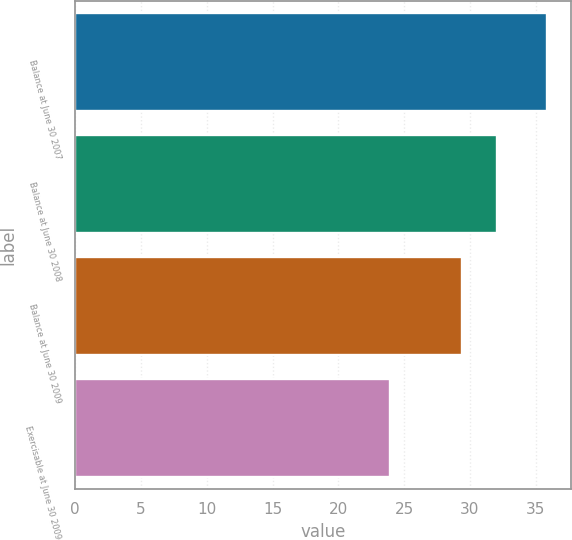Convert chart. <chart><loc_0><loc_0><loc_500><loc_500><bar_chart><fcel>Balance at June 30 2007<fcel>Balance at June 30 2008<fcel>Balance at June 30 2009<fcel>Exercisable at June 30 2009<nl><fcel>35.9<fcel>32.1<fcel>29.4<fcel>23.9<nl></chart> 